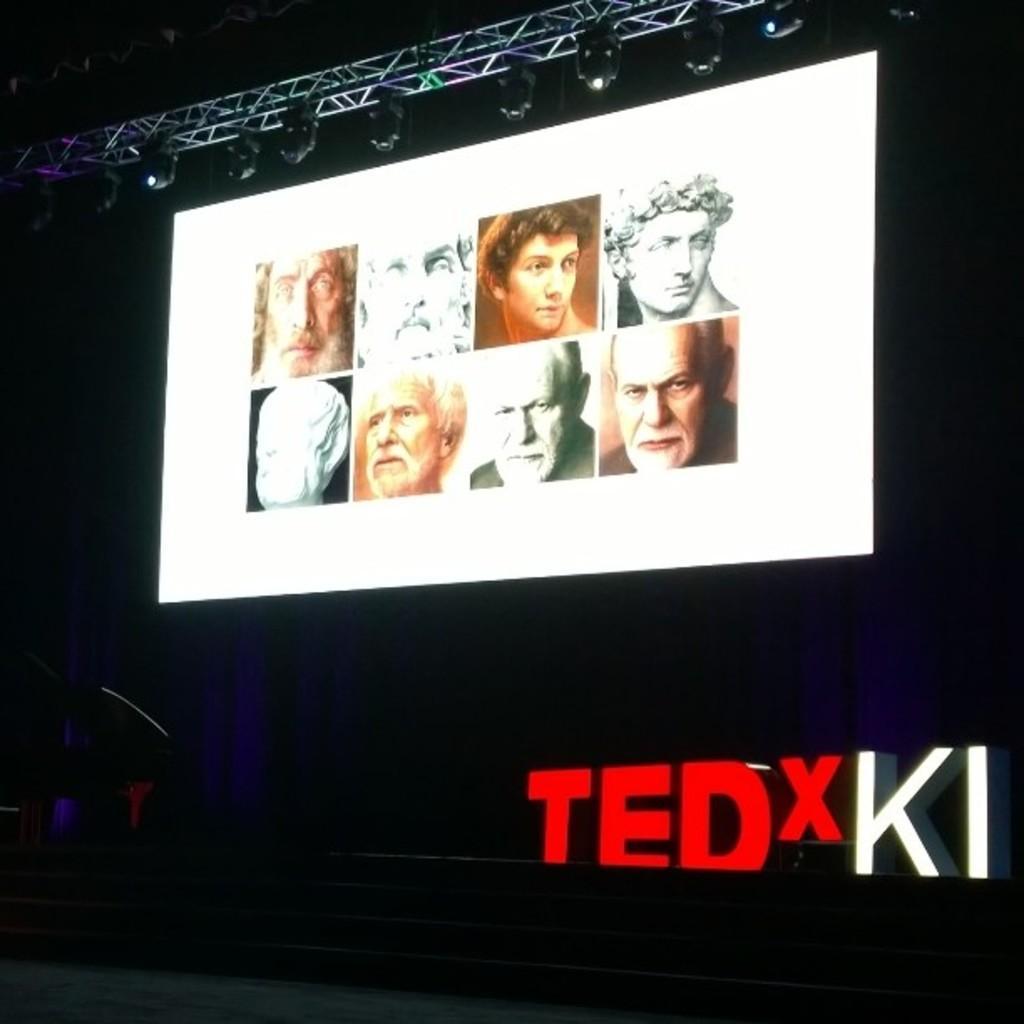Describe this image in one or two sentences. In this image there is a screen on the stage on which we can see there are so many people photos, under that there is some text. 